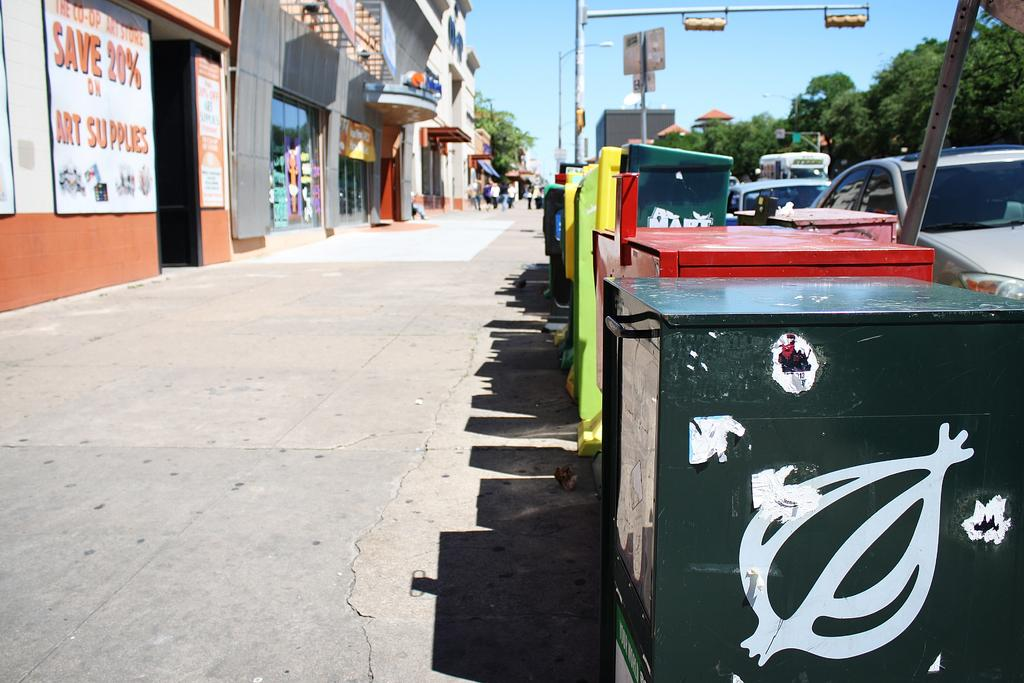<image>
Present a compact description of the photo's key features. White sign on a building that says save 20%. 